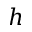<formula> <loc_0><loc_0><loc_500><loc_500>h</formula> 